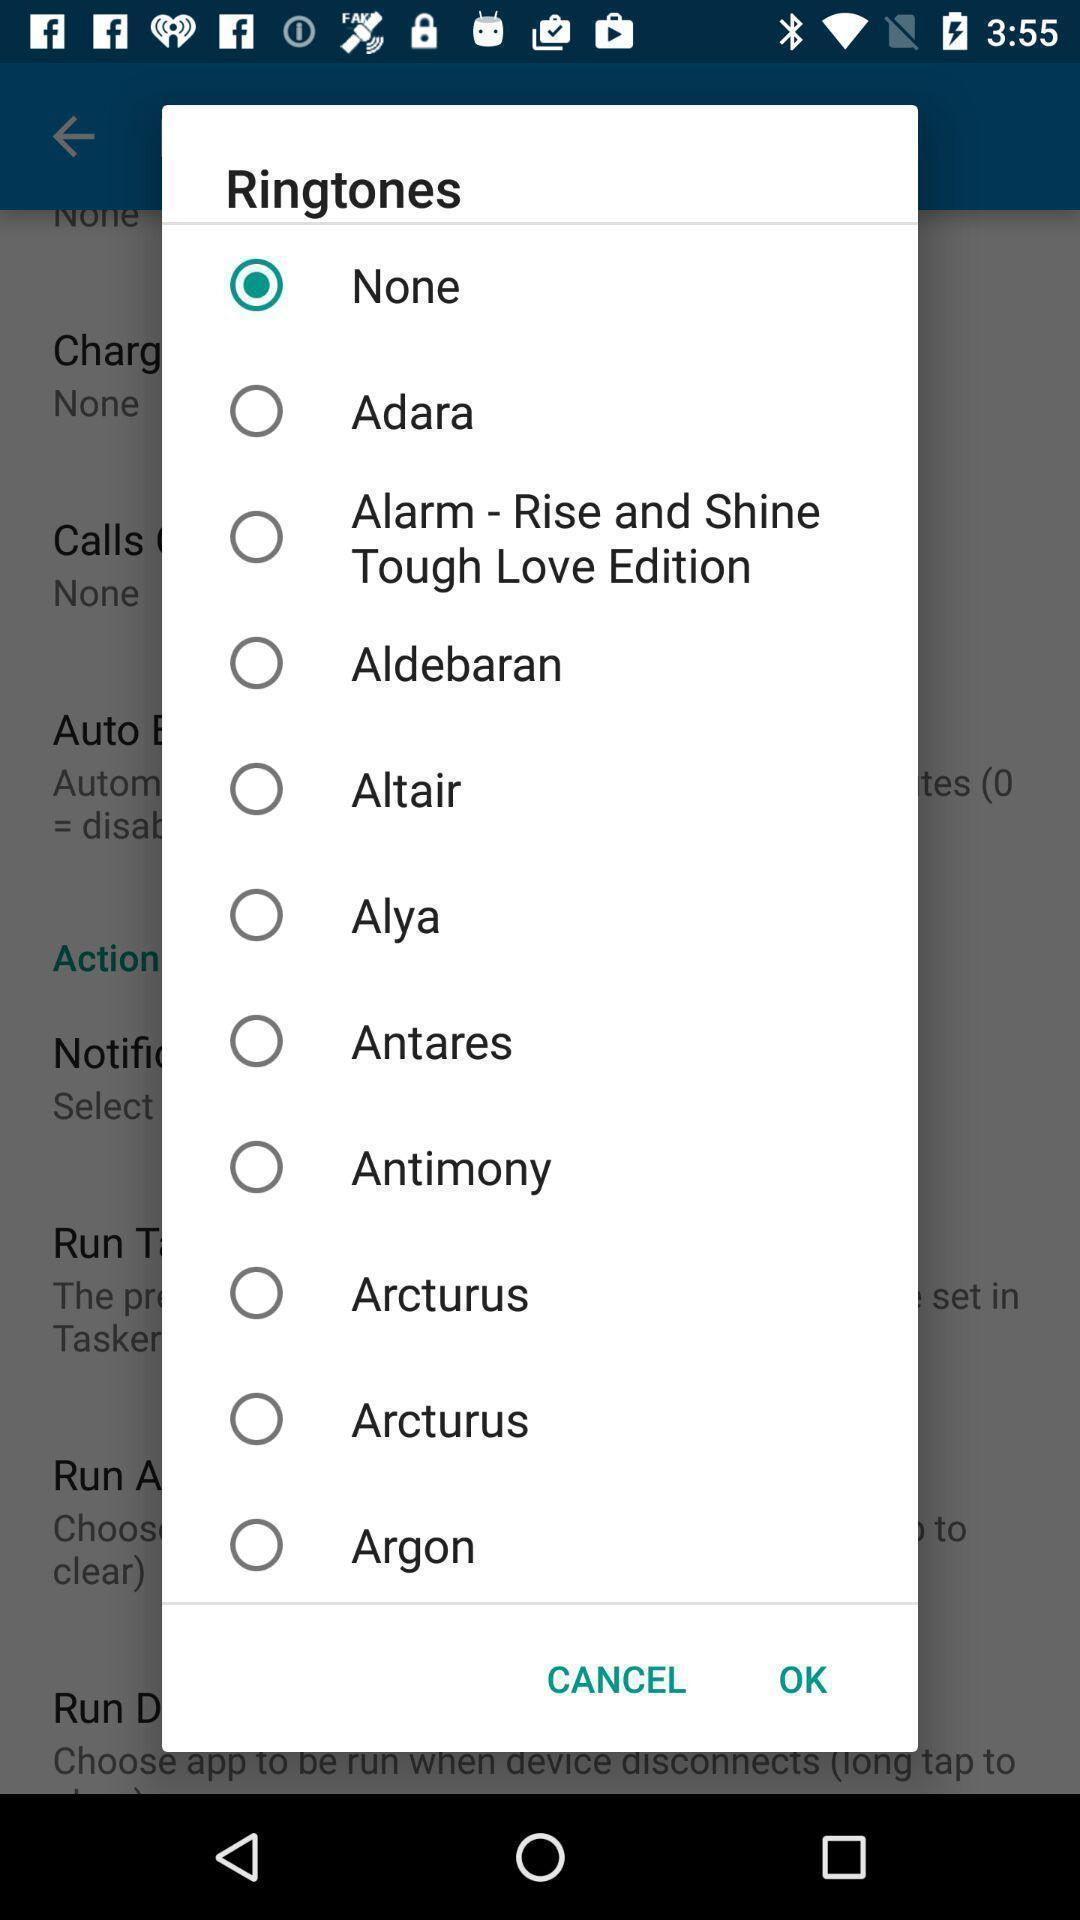Summarize the information in this screenshot. Pop-up to select a ringtone. 